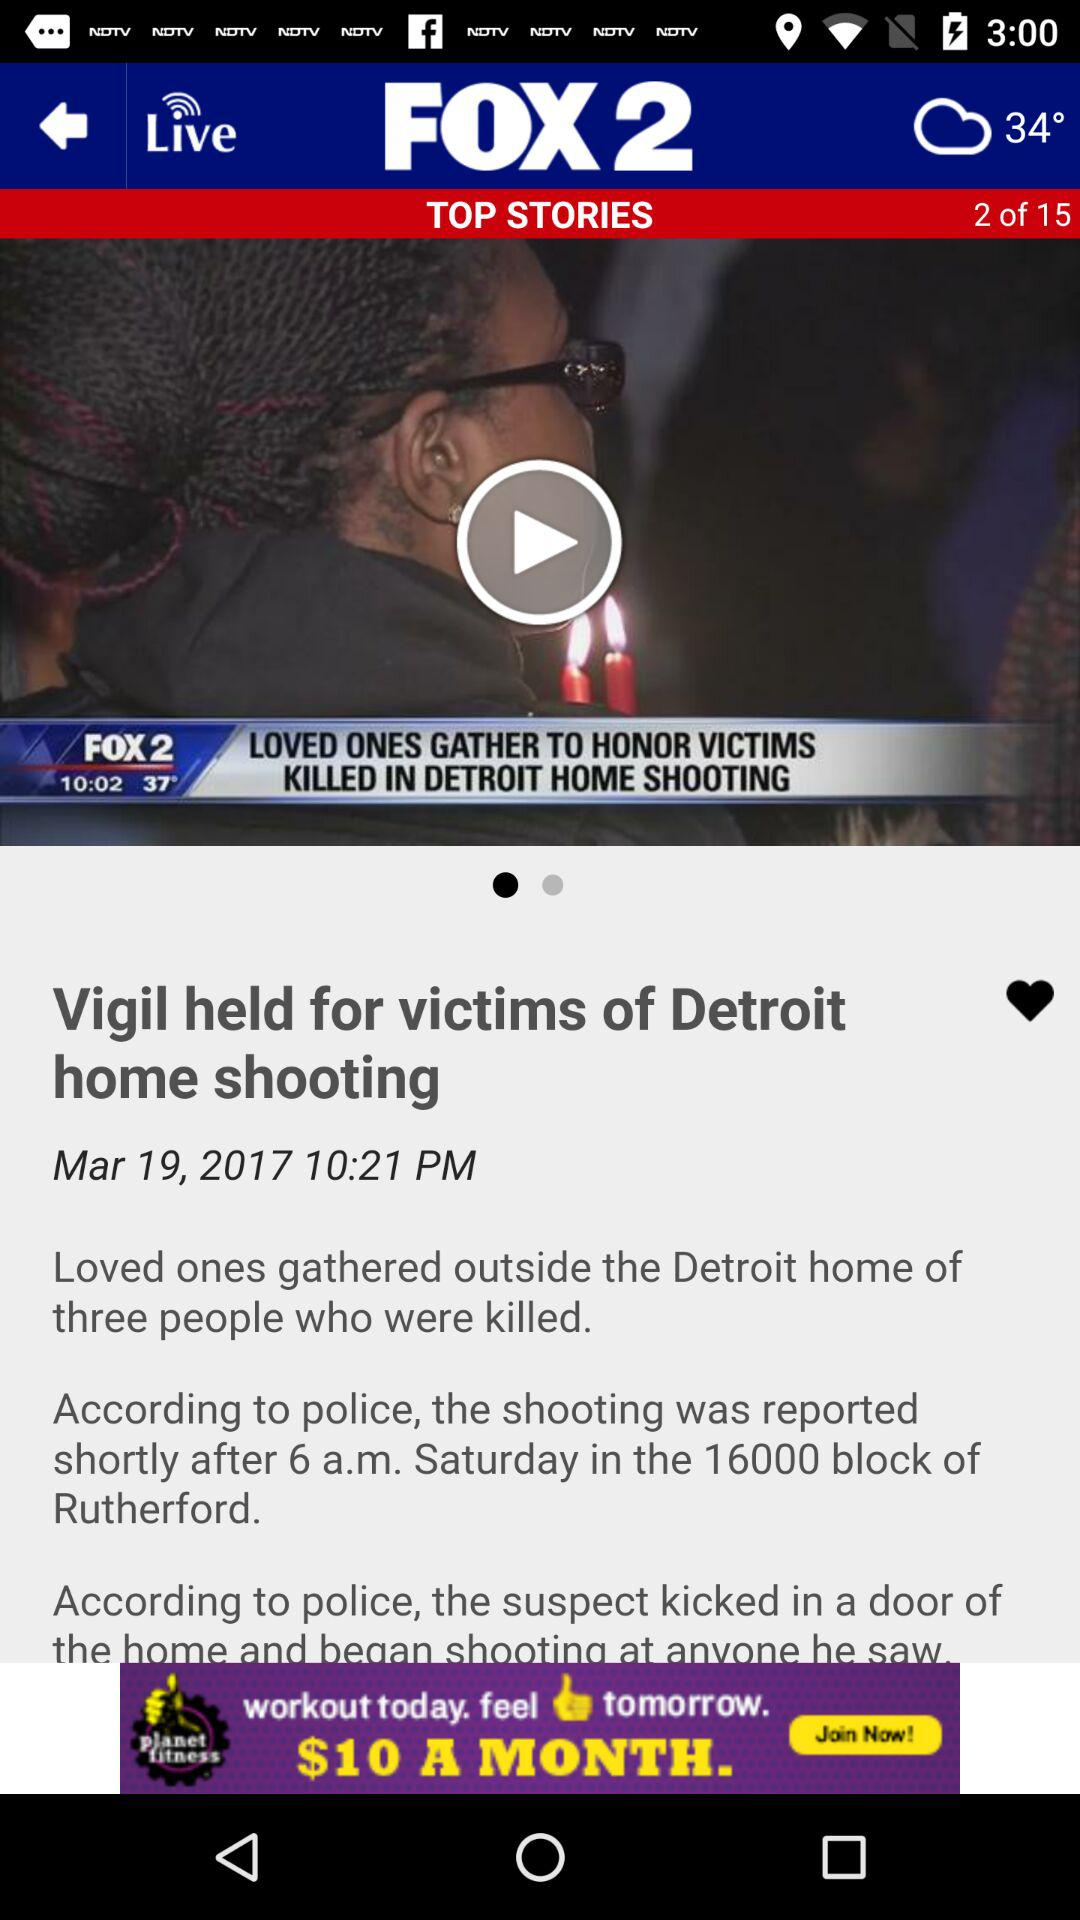What is the headline of the article? The headline of the article is "Vigil held for victims of Detroit home shooting". 